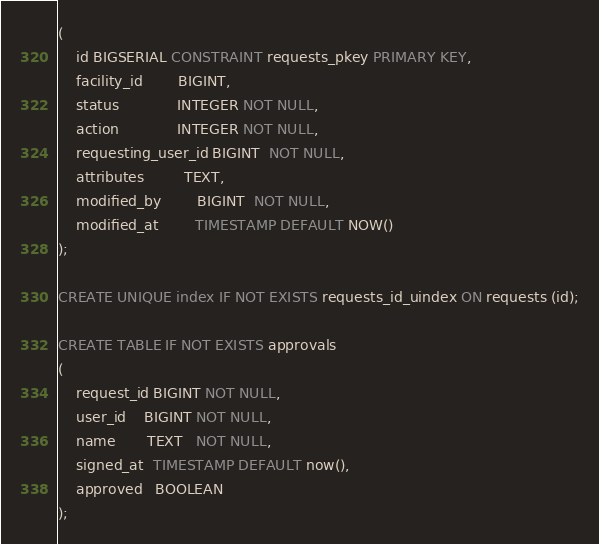Convert code to text. <code><loc_0><loc_0><loc_500><loc_500><_SQL_>(
    id BIGSERIAL CONSTRAINT requests_pkey PRIMARY KEY,
    facility_id        BIGINT,
    status             INTEGER NOT NULL,
    action             INTEGER NOT NULL,
    requesting_user_id BIGINT  NOT NULL,
    attributes         TEXT,
    modified_by        BIGINT  NOT NULL,
    modified_at        TIMESTAMP DEFAULT NOW()
);

CREATE UNIQUE index IF NOT EXISTS requests_id_uindex ON requests (id);

CREATE TABLE IF NOT EXISTS approvals
(
    request_id BIGINT NOT NULL,
    user_id    BIGINT NOT NULL,
    name       TEXT   NOT NULL,
    signed_at  TIMESTAMP DEFAULT now(),
    approved   BOOLEAN
);</code> 